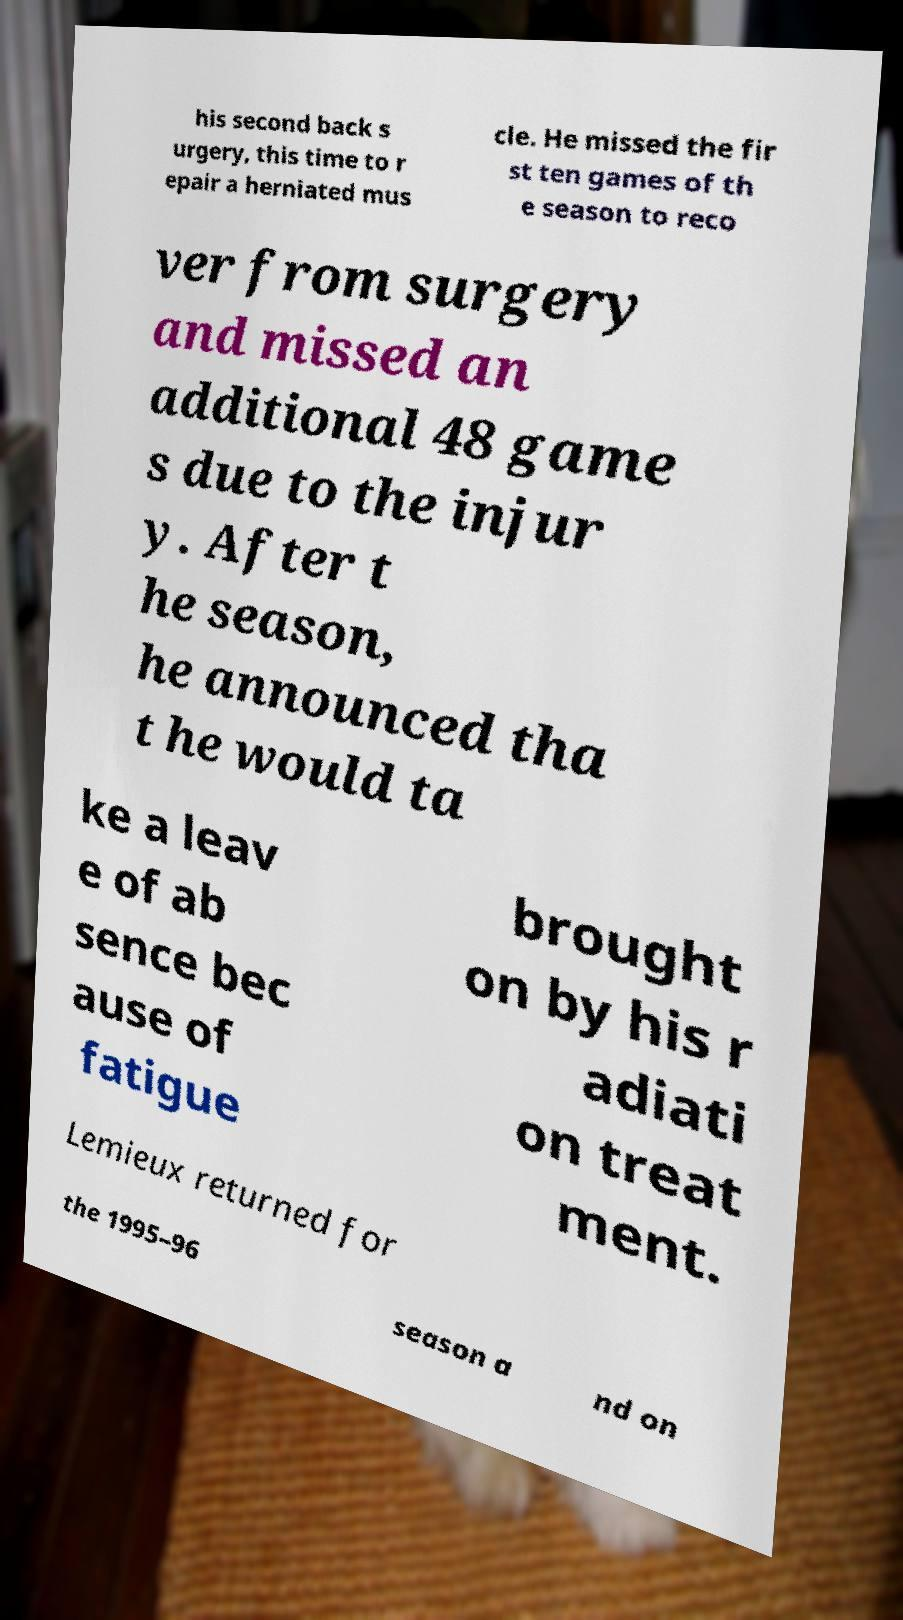Could you extract and type out the text from this image? his second back s urgery, this time to r epair a herniated mus cle. He missed the fir st ten games of th e season to reco ver from surgery and missed an additional 48 game s due to the injur y. After t he season, he announced tha t he would ta ke a leav e of ab sence bec ause of fatigue brought on by his r adiati on treat ment. Lemieux returned for the 1995–96 season a nd on 